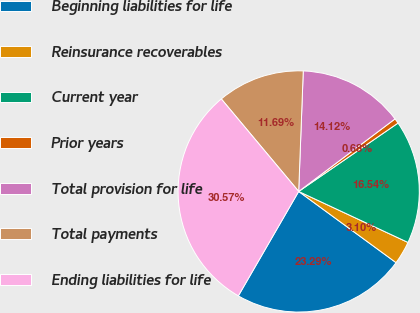Convert chart. <chart><loc_0><loc_0><loc_500><loc_500><pie_chart><fcel>Beginning liabilities for life<fcel>Reinsurance recoverables<fcel>Current year<fcel>Prior years<fcel>Total provision for life<fcel>Total payments<fcel>Ending liabilities for life<nl><fcel>23.29%<fcel>3.1%<fcel>16.54%<fcel>0.68%<fcel>14.12%<fcel>11.69%<fcel>30.57%<nl></chart> 